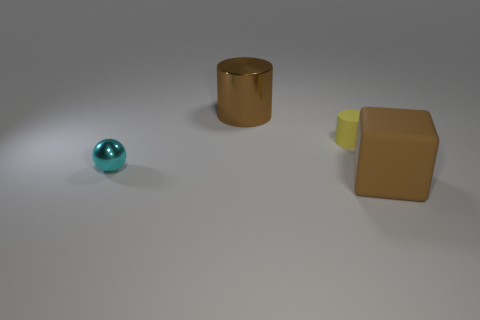Add 2 rubber cylinders. How many objects exist? 6 Subtract all cubes. How many objects are left? 3 Subtract 1 brown cubes. How many objects are left? 3 Subtract all small yellow things. Subtract all metal things. How many objects are left? 1 Add 1 tiny cyan metallic objects. How many tiny cyan metallic objects are left? 2 Add 1 yellow matte cubes. How many yellow matte cubes exist? 1 